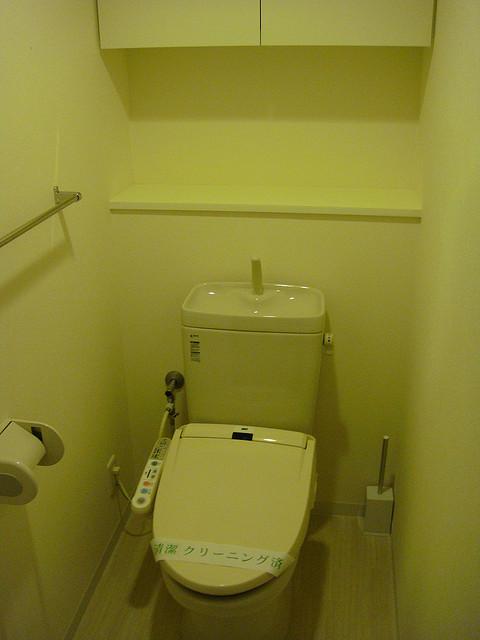Can you see toilet paper?
Keep it brief. Yes. What material is on the wall?
Quick response, please. Drywall. What does the sign say happened to the toilet?
Concise answer only. Sanitized. Yes the lid is up?
Concise answer only. No. Was this bathroom recently cleaned?
Write a very short answer. Yes. What color is the toilet bowl brush?
Short answer required. White. What writings are on the seat?
Write a very short answer. Chinese. 